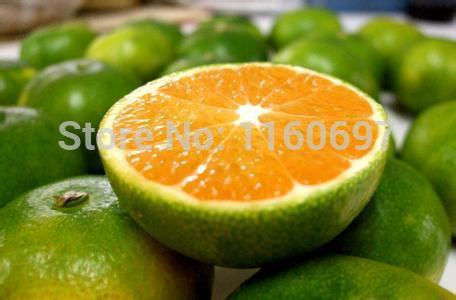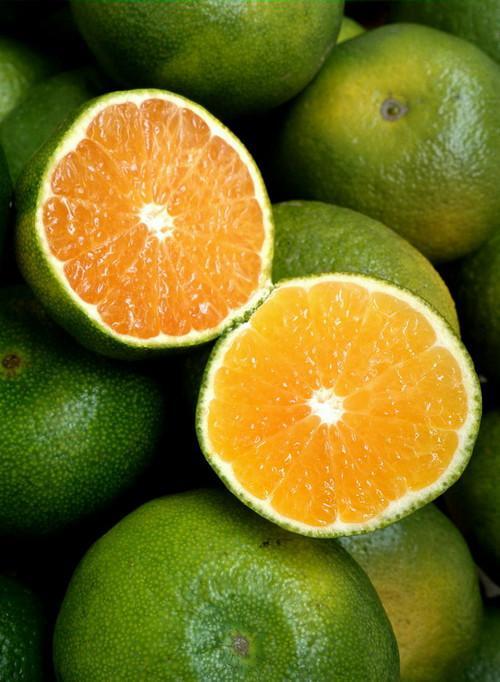The first image is the image on the left, the second image is the image on the right. Analyze the images presented: Is the assertion "The fruit in only ONE of the images was cut with a knife." valid? Answer yes or no. No. 